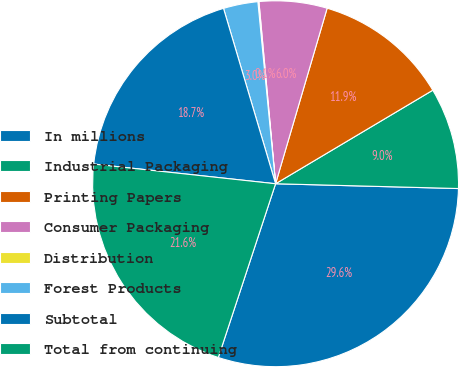Convert chart to OTSL. <chart><loc_0><loc_0><loc_500><loc_500><pie_chart><fcel>In millions<fcel>Industrial Packaging<fcel>Printing Papers<fcel>Consumer Packaging<fcel>Distribution<fcel>Forest Products<fcel>Subtotal<fcel>Total from continuing<nl><fcel>29.65%<fcel>8.96%<fcel>11.91%<fcel>6.0%<fcel>0.09%<fcel>3.05%<fcel>18.69%<fcel>21.65%<nl></chart> 